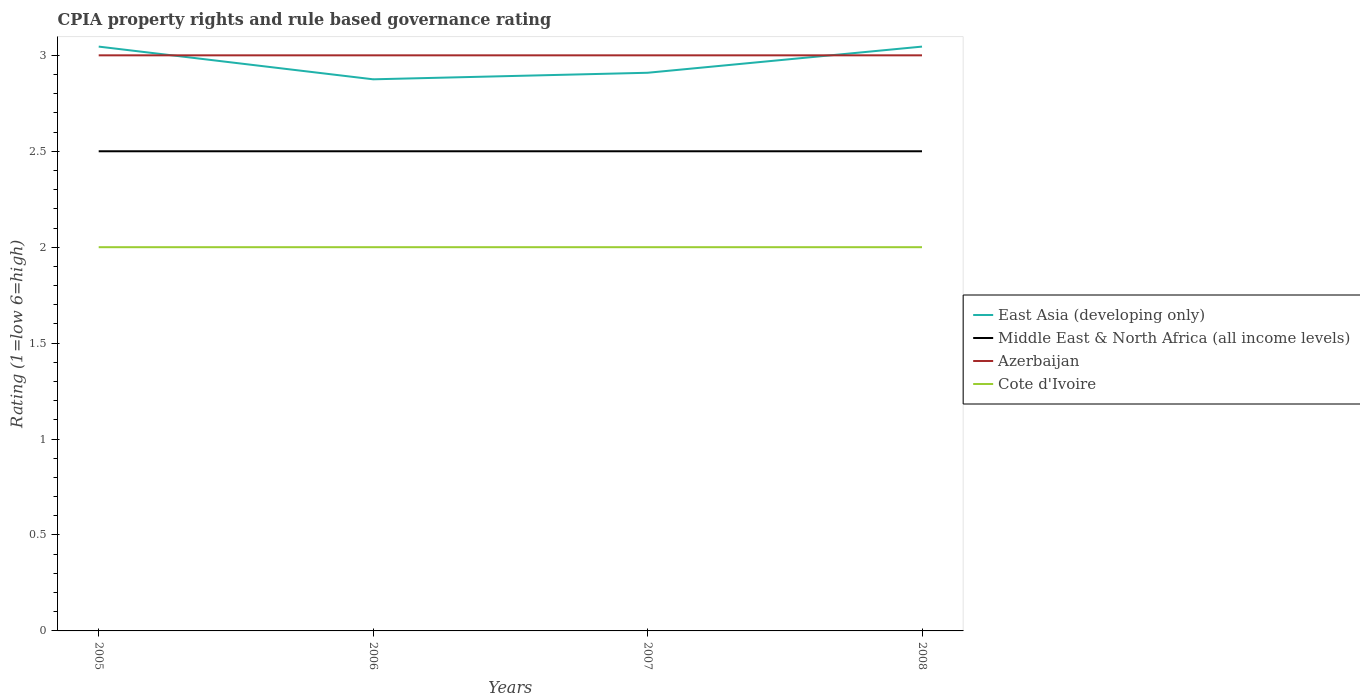How many different coloured lines are there?
Give a very brief answer. 4. Does the line corresponding to Cote d'Ivoire intersect with the line corresponding to East Asia (developing only)?
Offer a very short reply. No. Is the number of lines equal to the number of legend labels?
Give a very brief answer. Yes. Across all years, what is the maximum CPIA rating in Azerbaijan?
Provide a succinct answer. 3. What is the total CPIA rating in Middle East & North Africa (all income levels) in the graph?
Provide a short and direct response. 0. What is the difference between the highest and the second highest CPIA rating in Cote d'Ivoire?
Keep it short and to the point. 0. What is the difference between the highest and the lowest CPIA rating in Middle East & North Africa (all income levels)?
Ensure brevity in your answer.  0. How many years are there in the graph?
Offer a terse response. 4. Are the values on the major ticks of Y-axis written in scientific E-notation?
Make the answer very short. No. Does the graph contain any zero values?
Provide a succinct answer. No. Where does the legend appear in the graph?
Provide a short and direct response. Center right. What is the title of the graph?
Provide a short and direct response. CPIA property rights and rule based governance rating. Does "Europe(all income levels)" appear as one of the legend labels in the graph?
Offer a terse response. No. What is the Rating (1=low 6=high) of East Asia (developing only) in 2005?
Offer a terse response. 3.05. What is the Rating (1=low 6=high) in Middle East & North Africa (all income levels) in 2005?
Your response must be concise. 2.5. What is the Rating (1=low 6=high) in Azerbaijan in 2005?
Give a very brief answer. 3. What is the Rating (1=low 6=high) in Cote d'Ivoire in 2005?
Offer a terse response. 2. What is the Rating (1=low 6=high) of East Asia (developing only) in 2006?
Offer a very short reply. 2.88. What is the Rating (1=low 6=high) in Cote d'Ivoire in 2006?
Give a very brief answer. 2. What is the Rating (1=low 6=high) in East Asia (developing only) in 2007?
Offer a very short reply. 2.91. What is the Rating (1=low 6=high) of Azerbaijan in 2007?
Ensure brevity in your answer.  3. What is the Rating (1=low 6=high) in Cote d'Ivoire in 2007?
Your answer should be compact. 2. What is the Rating (1=low 6=high) of East Asia (developing only) in 2008?
Provide a short and direct response. 3.05. What is the Rating (1=low 6=high) in Cote d'Ivoire in 2008?
Provide a succinct answer. 2. Across all years, what is the maximum Rating (1=low 6=high) of East Asia (developing only)?
Offer a terse response. 3.05. Across all years, what is the minimum Rating (1=low 6=high) in East Asia (developing only)?
Keep it short and to the point. 2.88. Across all years, what is the minimum Rating (1=low 6=high) of Azerbaijan?
Ensure brevity in your answer.  3. Across all years, what is the minimum Rating (1=low 6=high) in Cote d'Ivoire?
Keep it short and to the point. 2. What is the total Rating (1=low 6=high) of East Asia (developing only) in the graph?
Keep it short and to the point. 11.88. What is the difference between the Rating (1=low 6=high) of East Asia (developing only) in 2005 and that in 2006?
Provide a short and direct response. 0.17. What is the difference between the Rating (1=low 6=high) of Cote d'Ivoire in 2005 and that in 2006?
Give a very brief answer. 0. What is the difference between the Rating (1=low 6=high) in East Asia (developing only) in 2005 and that in 2007?
Your answer should be very brief. 0.14. What is the difference between the Rating (1=low 6=high) of East Asia (developing only) in 2005 and that in 2008?
Your answer should be very brief. 0. What is the difference between the Rating (1=low 6=high) of Middle East & North Africa (all income levels) in 2005 and that in 2008?
Ensure brevity in your answer.  0. What is the difference between the Rating (1=low 6=high) in Azerbaijan in 2005 and that in 2008?
Keep it short and to the point. 0. What is the difference between the Rating (1=low 6=high) in Cote d'Ivoire in 2005 and that in 2008?
Your response must be concise. 0. What is the difference between the Rating (1=low 6=high) of East Asia (developing only) in 2006 and that in 2007?
Offer a terse response. -0.03. What is the difference between the Rating (1=low 6=high) of Cote d'Ivoire in 2006 and that in 2007?
Provide a succinct answer. 0. What is the difference between the Rating (1=low 6=high) in East Asia (developing only) in 2006 and that in 2008?
Your response must be concise. -0.17. What is the difference between the Rating (1=low 6=high) of Middle East & North Africa (all income levels) in 2006 and that in 2008?
Give a very brief answer. 0. What is the difference between the Rating (1=low 6=high) in Cote d'Ivoire in 2006 and that in 2008?
Your answer should be compact. 0. What is the difference between the Rating (1=low 6=high) in East Asia (developing only) in 2007 and that in 2008?
Provide a short and direct response. -0.14. What is the difference between the Rating (1=low 6=high) of East Asia (developing only) in 2005 and the Rating (1=low 6=high) of Middle East & North Africa (all income levels) in 2006?
Your answer should be very brief. 0.55. What is the difference between the Rating (1=low 6=high) of East Asia (developing only) in 2005 and the Rating (1=low 6=high) of Azerbaijan in 2006?
Ensure brevity in your answer.  0.05. What is the difference between the Rating (1=low 6=high) in East Asia (developing only) in 2005 and the Rating (1=low 6=high) in Cote d'Ivoire in 2006?
Ensure brevity in your answer.  1.05. What is the difference between the Rating (1=low 6=high) in Middle East & North Africa (all income levels) in 2005 and the Rating (1=low 6=high) in Azerbaijan in 2006?
Give a very brief answer. -0.5. What is the difference between the Rating (1=low 6=high) in Middle East & North Africa (all income levels) in 2005 and the Rating (1=low 6=high) in Cote d'Ivoire in 2006?
Your answer should be compact. 0.5. What is the difference between the Rating (1=low 6=high) in Azerbaijan in 2005 and the Rating (1=low 6=high) in Cote d'Ivoire in 2006?
Offer a very short reply. 1. What is the difference between the Rating (1=low 6=high) in East Asia (developing only) in 2005 and the Rating (1=low 6=high) in Middle East & North Africa (all income levels) in 2007?
Make the answer very short. 0.55. What is the difference between the Rating (1=low 6=high) in East Asia (developing only) in 2005 and the Rating (1=low 6=high) in Azerbaijan in 2007?
Offer a very short reply. 0.05. What is the difference between the Rating (1=low 6=high) of East Asia (developing only) in 2005 and the Rating (1=low 6=high) of Cote d'Ivoire in 2007?
Provide a succinct answer. 1.05. What is the difference between the Rating (1=low 6=high) of East Asia (developing only) in 2005 and the Rating (1=low 6=high) of Middle East & North Africa (all income levels) in 2008?
Give a very brief answer. 0.55. What is the difference between the Rating (1=low 6=high) in East Asia (developing only) in 2005 and the Rating (1=low 6=high) in Azerbaijan in 2008?
Give a very brief answer. 0.05. What is the difference between the Rating (1=low 6=high) in East Asia (developing only) in 2005 and the Rating (1=low 6=high) in Cote d'Ivoire in 2008?
Keep it short and to the point. 1.05. What is the difference between the Rating (1=low 6=high) of East Asia (developing only) in 2006 and the Rating (1=low 6=high) of Azerbaijan in 2007?
Your response must be concise. -0.12. What is the difference between the Rating (1=low 6=high) in Middle East & North Africa (all income levels) in 2006 and the Rating (1=low 6=high) in Azerbaijan in 2007?
Ensure brevity in your answer.  -0.5. What is the difference between the Rating (1=low 6=high) of Azerbaijan in 2006 and the Rating (1=low 6=high) of Cote d'Ivoire in 2007?
Your response must be concise. 1. What is the difference between the Rating (1=low 6=high) of East Asia (developing only) in 2006 and the Rating (1=low 6=high) of Middle East & North Africa (all income levels) in 2008?
Ensure brevity in your answer.  0.38. What is the difference between the Rating (1=low 6=high) in East Asia (developing only) in 2006 and the Rating (1=low 6=high) in Azerbaijan in 2008?
Provide a short and direct response. -0.12. What is the difference between the Rating (1=low 6=high) in Middle East & North Africa (all income levels) in 2006 and the Rating (1=low 6=high) in Azerbaijan in 2008?
Your answer should be compact. -0.5. What is the difference between the Rating (1=low 6=high) of Middle East & North Africa (all income levels) in 2006 and the Rating (1=low 6=high) of Cote d'Ivoire in 2008?
Keep it short and to the point. 0.5. What is the difference between the Rating (1=low 6=high) in Azerbaijan in 2006 and the Rating (1=low 6=high) in Cote d'Ivoire in 2008?
Ensure brevity in your answer.  1. What is the difference between the Rating (1=low 6=high) in East Asia (developing only) in 2007 and the Rating (1=low 6=high) in Middle East & North Africa (all income levels) in 2008?
Provide a succinct answer. 0.41. What is the difference between the Rating (1=low 6=high) of East Asia (developing only) in 2007 and the Rating (1=low 6=high) of Azerbaijan in 2008?
Provide a succinct answer. -0.09. What is the difference between the Rating (1=low 6=high) in Middle East & North Africa (all income levels) in 2007 and the Rating (1=low 6=high) in Cote d'Ivoire in 2008?
Your answer should be very brief. 0.5. What is the difference between the Rating (1=low 6=high) of Azerbaijan in 2007 and the Rating (1=low 6=high) of Cote d'Ivoire in 2008?
Offer a very short reply. 1. What is the average Rating (1=low 6=high) in East Asia (developing only) per year?
Your response must be concise. 2.97. What is the average Rating (1=low 6=high) in Middle East & North Africa (all income levels) per year?
Give a very brief answer. 2.5. In the year 2005, what is the difference between the Rating (1=low 6=high) of East Asia (developing only) and Rating (1=low 6=high) of Middle East & North Africa (all income levels)?
Keep it short and to the point. 0.55. In the year 2005, what is the difference between the Rating (1=low 6=high) in East Asia (developing only) and Rating (1=low 6=high) in Azerbaijan?
Give a very brief answer. 0.05. In the year 2005, what is the difference between the Rating (1=low 6=high) in East Asia (developing only) and Rating (1=low 6=high) in Cote d'Ivoire?
Make the answer very short. 1.05. In the year 2006, what is the difference between the Rating (1=low 6=high) in East Asia (developing only) and Rating (1=low 6=high) in Azerbaijan?
Give a very brief answer. -0.12. In the year 2006, what is the difference between the Rating (1=low 6=high) in Middle East & North Africa (all income levels) and Rating (1=low 6=high) in Azerbaijan?
Your answer should be compact. -0.5. In the year 2007, what is the difference between the Rating (1=low 6=high) of East Asia (developing only) and Rating (1=low 6=high) of Middle East & North Africa (all income levels)?
Offer a terse response. 0.41. In the year 2007, what is the difference between the Rating (1=low 6=high) in East Asia (developing only) and Rating (1=low 6=high) in Azerbaijan?
Ensure brevity in your answer.  -0.09. In the year 2007, what is the difference between the Rating (1=low 6=high) of East Asia (developing only) and Rating (1=low 6=high) of Cote d'Ivoire?
Give a very brief answer. 0.91. In the year 2007, what is the difference between the Rating (1=low 6=high) of Middle East & North Africa (all income levels) and Rating (1=low 6=high) of Azerbaijan?
Provide a short and direct response. -0.5. In the year 2007, what is the difference between the Rating (1=low 6=high) in Azerbaijan and Rating (1=low 6=high) in Cote d'Ivoire?
Your response must be concise. 1. In the year 2008, what is the difference between the Rating (1=low 6=high) in East Asia (developing only) and Rating (1=low 6=high) in Middle East & North Africa (all income levels)?
Provide a succinct answer. 0.55. In the year 2008, what is the difference between the Rating (1=low 6=high) in East Asia (developing only) and Rating (1=low 6=high) in Azerbaijan?
Ensure brevity in your answer.  0.05. In the year 2008, what is the difference between the Rating (1=low 6=high) in East Asia (developing only) and Rating (1=low 6=high) in Cote d'Ivoire?
Ensure brevity in your answer.  1.05. In the year 2008, what is the difference between the Rating (1=low 6=high) in Middle East & North Africa (all income levels) and Rating (1=low 6=high) in Azerbaijan?
Give a very brief answer. -0.5. What is the ratio of the Rating (1=low 6=high) in East Asia (developing only) in 2005 to that in 2006?
Provide a succinct answer. 1.06. What is the ratio of the Rating (1=low 6=high) of Middle East & North Africa (all income levels) in 2005 to that in 2006?
Give a very brief answer. 1. What is the ratio of the Rating (1=low 6=high) of Azerbaijan in 2005 to that in 2006?
Keep it short and to the point. 1. What is the ratio of the Rating (1=low 6=high) of Cote d'Ivoire in 2005 to that in 2006?
Give a very brief answer. 1. What is the ratio of the Rating (1=low 6=high) of East Asia (developing only) in 2005 to that in 2007?
Provide a short and direct response. 1.05. What is the ratio of the Rating (1=low 6=high) in Middle East & North Africa (all income levels) in 2005 to that in 2007?
Provide a succinct answer. 1. What is the ratio of the Rating (1=low 6=high) of Azerbaijan in 2005 to that in 2007?
Make the answer very short. 1. What is the ratio of the Rating (1=low 6=high) in Middle East & North Africa (all income levels) in 2005 to that in 2008?
Your answer should be compact. 1. What is the ratio of the Rating (1=low 6=high) of East Asia (developing only) in 2006 to that in 2007?
Give a very brief answer. 0.99. What is the ratio of the Rating (1=low 6=high) in Azerbaijan in 2006 to that in 2007?
Make the answer very short. 1. What is the ratio of the Rating (1=low 6=high) in Cote d'Ivoire in 2006 to that in 2007?
Offer a very short reply. 1. What is the ratio of the Rating (1=low 6=high) of East Asia (developing only) in 2006 to that in 2008?
Make the answer very short. 0.94. What is the ratio of the Rating (1=low 6=high) in Middle East & North Africa (all income levels) in 2006 to that in 2008?
Your response must be concise. 1. What is the ratio of the Rating (1=low 6=high) in Azerbaijan in 2006 to that in 2008?
Keep it short and to the point. 1. What is the ratio of the Rating (1=low 6=high) in Cote d'Ivoire in 2006 to that in 2008?
Provide a short and direct response. 1. What is the ratio of the Rating (1=low 6=high) of East Asia (developing only) in 2007 to that in 2008?
Make the answer very short. 0.96. What is the ratio of the Rating (1=low 6=high) of Azerbaijan in 2007 to that in 2008?
Ensure brevity in your answer.  1. What is the ratio of the Rating (1=low 6=high) in Cote d'Ivoire in 2007 to that in 2008?
Your answer should be very brief. 1. What is the difference between the highest and the lowest Rating (1=low 6=high) of East Asia (developing only)?
Provide a short and direct response. 0.17. What is the difference between the highest and the lowest Rating (1=low 6=high) in Middle East & North Africa (all income levels)?
Give a very brief answer. 0. What is the difference between the highest and the lowest Rating (1=low 6=high) of Azerbaijan?
Your answer should be very brief. 0. 